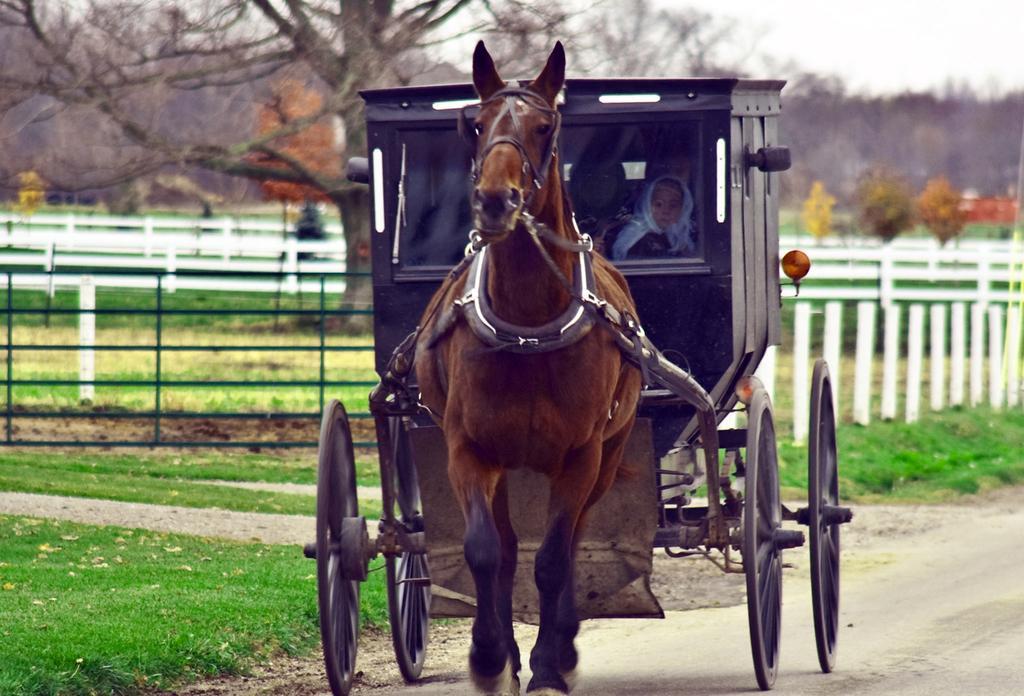Could you give a brief overview of what you see in this image? In the center of the image we can see a horse cart and there are people sitting in the cart. In the background there is a fence, trees and sky. At the bottom there is grass. 